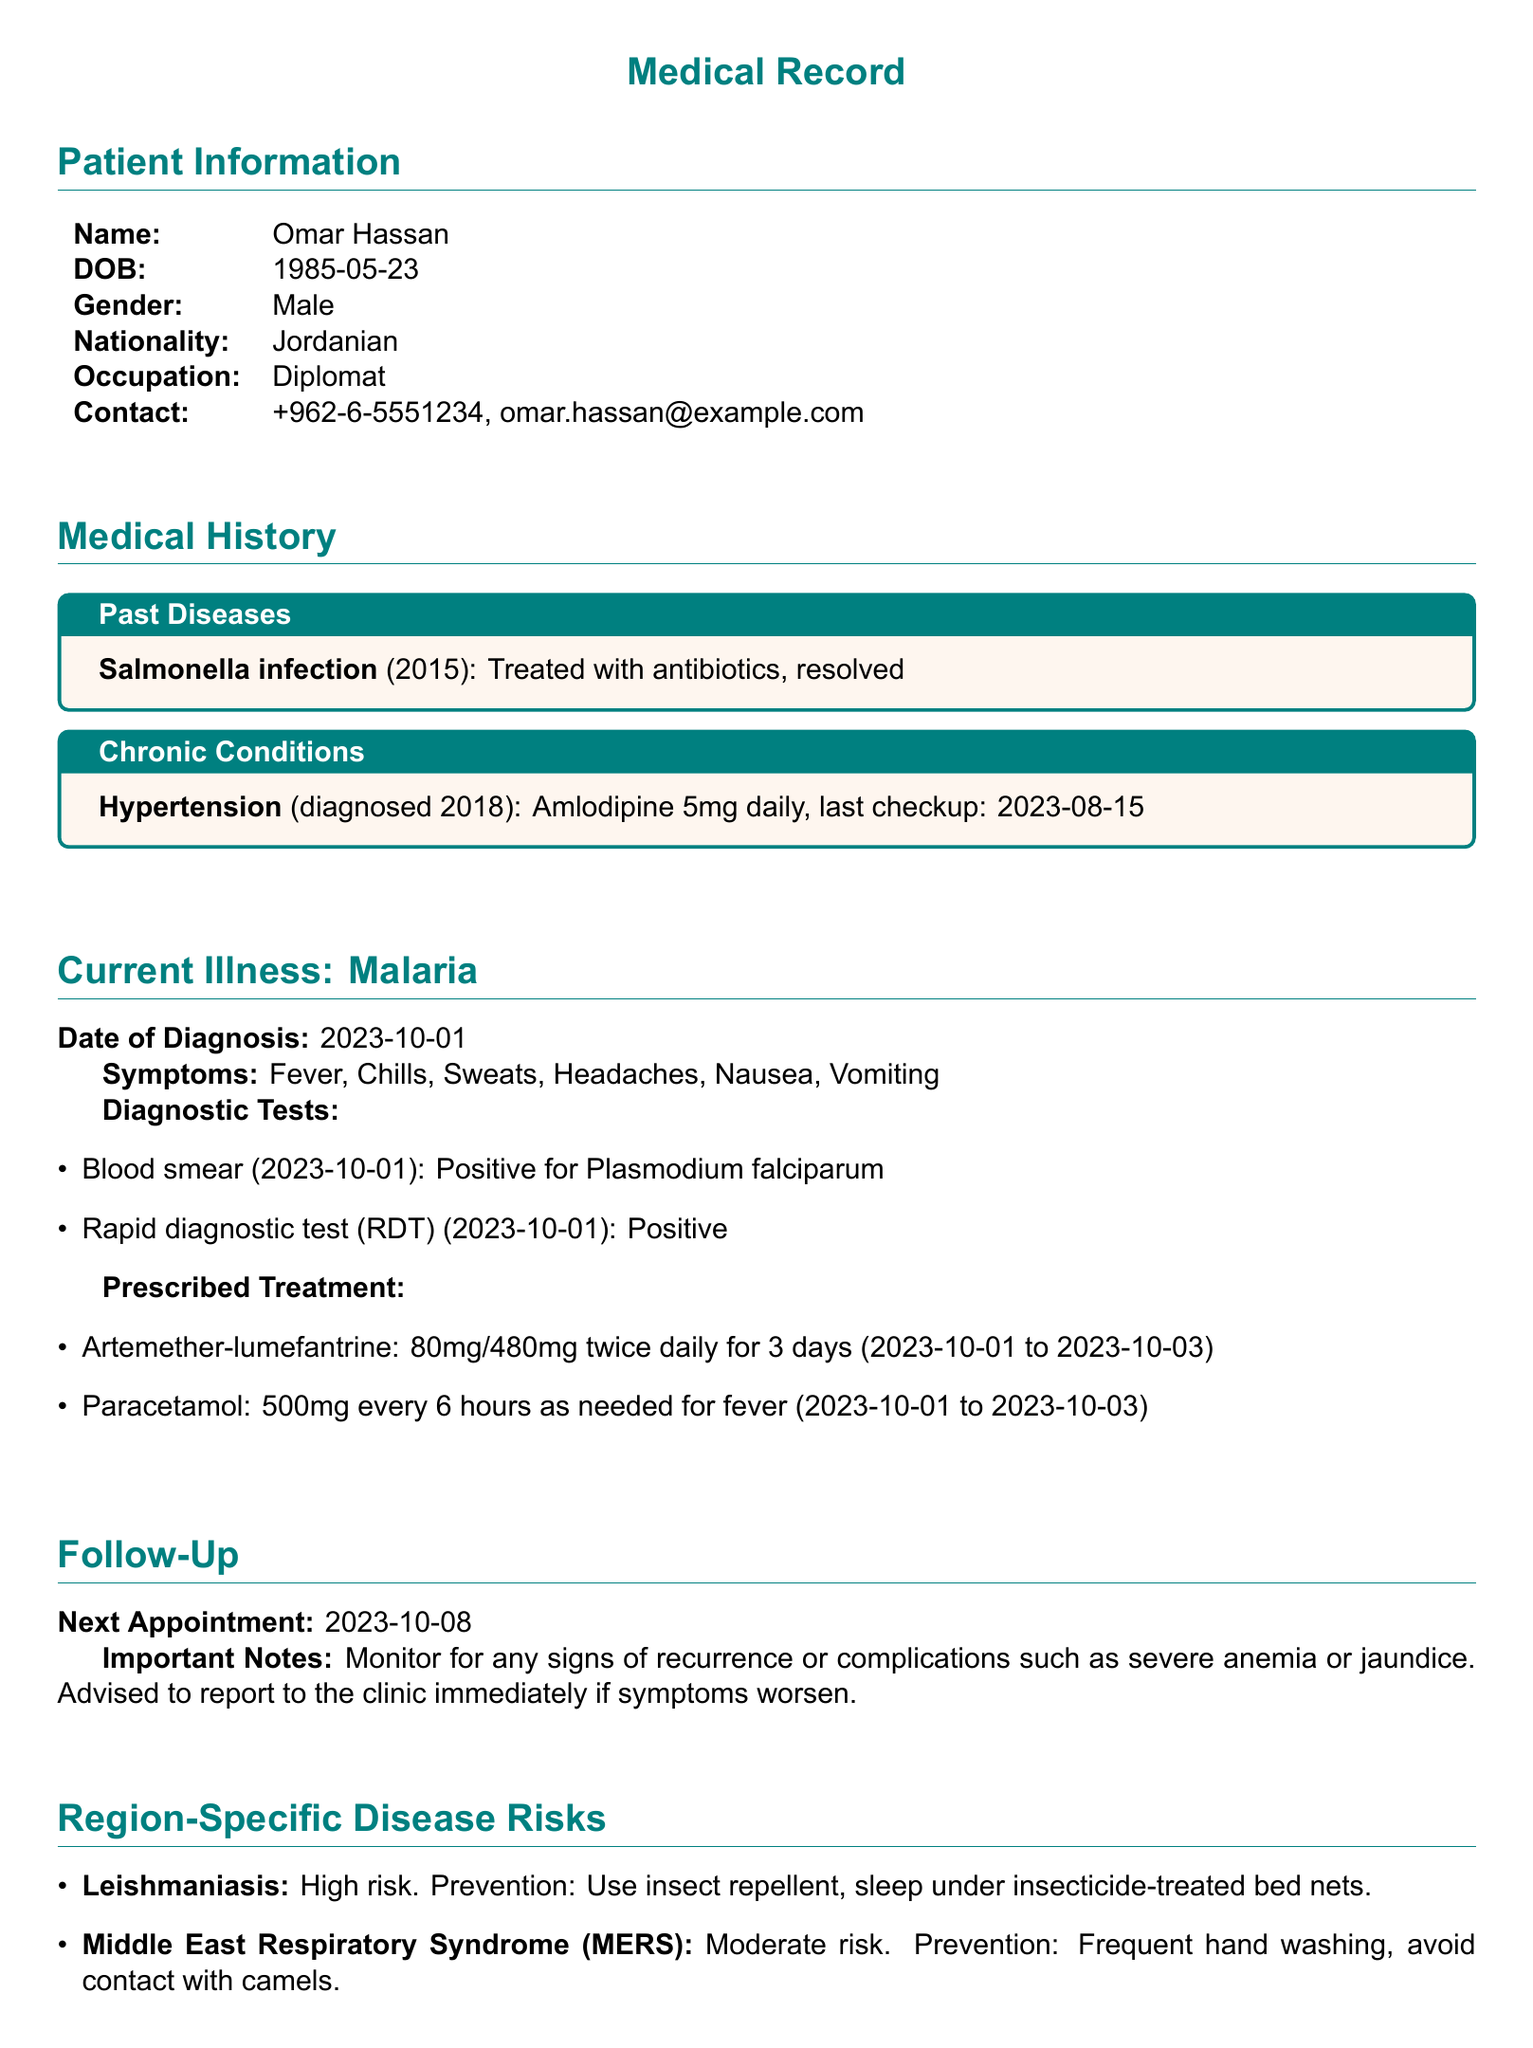What is the patient's name? The patient's name is listed in the Patient Information section.
Answer: Omar Hassan What is the date of diagnosis for malaria? The date of diagnosis for malaria is mentioned under Current Illness.
Answer: 2023-10-01 What symptoms did the patient present with? The symptoms are enumerated under the Current Illness section.
Answer: Fever, Chills, Sweats, Headaches, Nausea, Vomiting What medication is prescribed for malaria? The prescribed treatment lists the medications under the Prescribed Treatment section.
Answer: Artemether-lumefantrine What is the follow-up appointment date? The next appointment date is given in the Follow-Up section.
Answer: 2023-10-08 What chronic condition was diagnosed in 2018? The chronic conditions are outlined in the Medical History section.
Answer: Hypertension What is the recommended prevention for Leishmaniasis? The prevention measures are mentioned in the Region-Specific Disease Risks section.
Answer: Use insect repellent, sleep under insecticide-treated bed nets How often is Paracetamol to be taken? The frequency of the prescribed Paracetamol is specified under Prescribed Treatment.
Answer: Every 6 hours as needed 